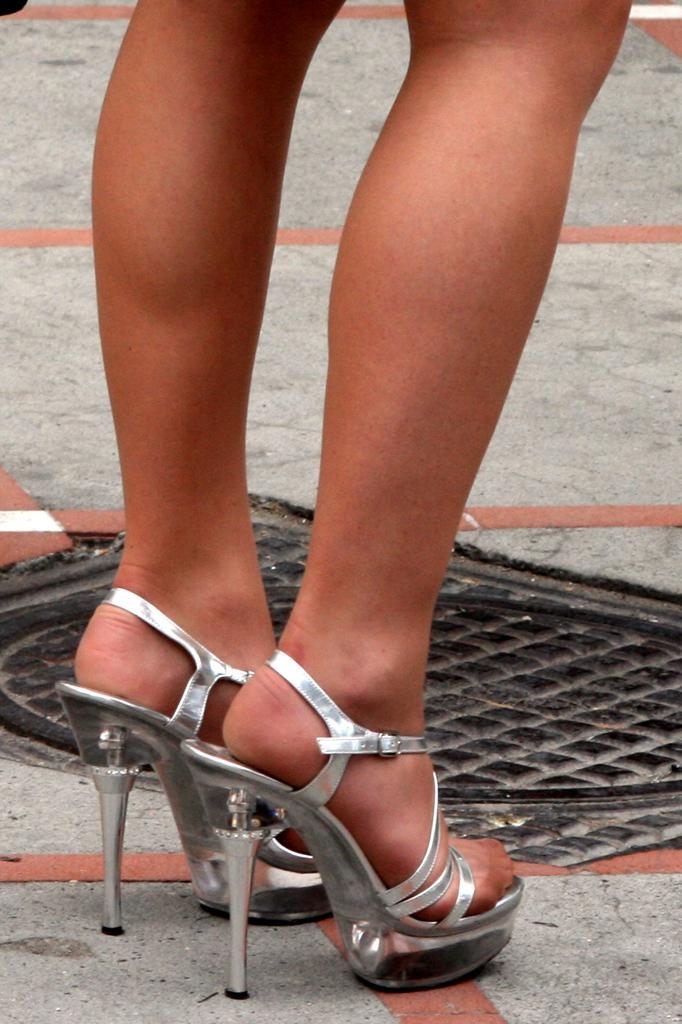Please provide a concise description of this image. In this image I can see a person wearing silver colored footwear is standing on the ground. I can see the black colored manhole lid. 